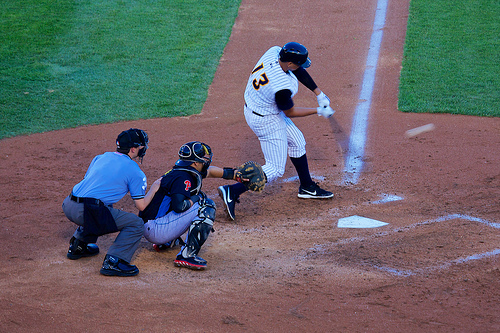Who do you think is wearing a shoe? The player at bat and the umpire both wear shoes appropriate for their roles and movement needs on the baseball field. 